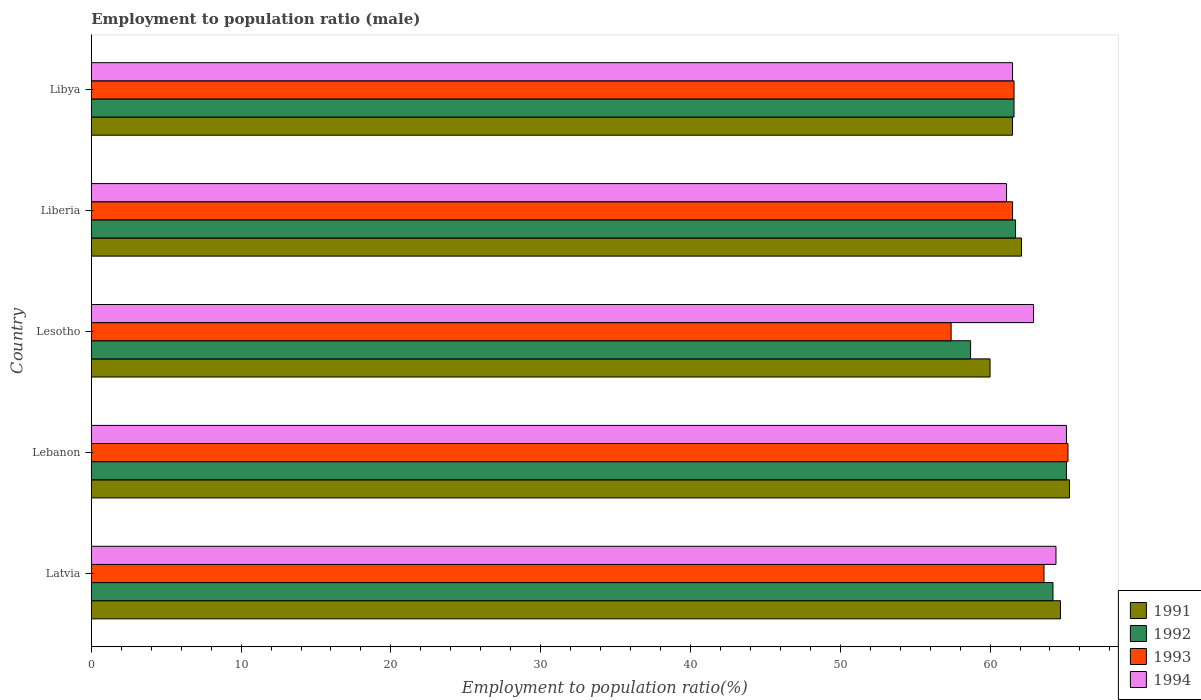How many groups of bars are there?
Make the answer very short. 5. How many bars are there on the 2nd tick from the top?
Offer a very short reply. 4. What is the label of the 2nd group of bars from the top?
Your answer should be compact. Liberia. In how many cases, is the number of bars for a given country not equal to the number of legend labels?
Provide a short and direct response. 0. What is the employment to population ratio in 1992 in Liberia?
Provide a succinct answer. 61.7. Across all countries, what is the maximum employment to population ratio in 1991?
Ensure brevity in your answer.  65.3. Across all countries, what is the minimum employment to population ratio in 1993?
Offer a terse response. 57.4. In which country was the employment to population ratio in 1991 maximum?
Keep it short and to the point. Lebanon. In which country was the employment to population ratio in 1991 minimum?
Your answer should be very brief. Lesotho. What is the total employment to population ratio in 1994 in the graph?
Offer a terse response. 315. What is the difference between the employment to population ratio in 1993 in Lesotho and that in Libya?
Your answer should be very brief. -4.2. What is the difference between the employment to population ratio in 1994 in Liberia and the employment to population ratio in 1992 in Lesotho?
Provide a succinct answer. 2.4. What is the average employment to population ratio in 1993 per country?
Ensure brevity in your answer.  61.86. What is the difference between the employment to population ratio in 1994 and employment to population ratio in 1991 in Lebanon?
Offer a very short reply. -0.2. What is the ratio of the employment to population ratio in 1991 in Latvia to that in Liberia?
Your response must be concise. 1.04. Is the employment to population ratio in 1991 in Lebanon less than that in Libya?
Provide a succinct answer. No. Is the difference between the employment to population ratio in 1994 in Latvia and Liberia greater than the difference between the employment to population ratio in 1991 in Latvia and Liberia?
Your answer should be very brief. Yes. What is the difference between the highest and the second highest employment to population ratio in 1991?
Your answer should be compact. 0.6. What is the difference between the highest and the lowest employment to population ratio in 1991?
Keep it short and to the point. 5.3. In how many countries, is the employment to population ratio in 1992 greater than the average employment to population ratio in 1992 taken over all countries?
Your answer should be compact. 2. What does the 2nd bar from the bottom in Liberia represents?
Your response must be concise. 1992. Is it the case that in every country, the sum of the employment to population ratio in 1994 and employment to population ratio in 1991 is greater than the employment to population ratio in 1992?
Keep it short and to the point. Yes. How many countries are there in the graph?
Your answer should be very brief. 5. How are the legend labels stacked?
Make the answer very short. Vertical. What is the title of the graph?
Your response must be concise. Employment to population ratio (male). What is the label or title of the Y-axis?
Ensure brevity in your answer.  Country. What is the Employment to population ratio(%) in 1991 in Latvia?
Ensure brevity in your answer.  64.7. What is the Employment to population ratio(%) of 1992 in Latvia?
Give a very brief answer. 64.2. What is the Employment to population ratio(%) of 1993 in Latvia?
Your answer should be very brief. 63.6. What is the Employment to population ratio(%) of 1994 in Latvia?
Provide a succinct answer. 64.4. What is the Employment to population ratio(%) of 1991 in Lebanon?
Provide a succinct answer. 65.3. What is the Employment to population ratio(%) of 1992 in Lebanon?
Your response must be concise. 65.1. What is the Employment to population ratio(%) in 1993 in Lebanon?
Give a very brief answer. 65.2. What is the Employment to population ratio(%) of 1994 in Lebanon?
Your answer should be very brief. 65.1. What is the Employment to population ratio(%) of 1991 in Lesotho?
Your answer should be very brief. 60. What is the Employment to population ratio(%) of 1992 in Lesotho?
Your response must be concise. 58.7. What is the Employment to population ratio(%) in 1993 in Lesotho?
Your answer should be very brief. 57.4. What is the Employment to population ratio(%) in 1994 in Lesotho?
Your answer should be very brief. 62.9. What is the Employment to population ratio(%) in 1991 in Liberia?
Provide a succinct answer. 62.1. What is the Employment to population ratio(%) of 1992 in Liberia?
Provide a short and direct response. 61.7. What is the Employment to population ratio(%) in 1993 in Liberia?
Ensure brevity in your answer.  61.5. What is the Employment to population ratio(%) in 1994 in Liberia?
Ensure brevity in your answer.  61.1. What is the Employment to population ratio(%) of 1991 in Libya?
Keep it short and to the point. 61.5. What is the Employment to population ratio(%) of 1992 in Libya?
Your answer should be compact. 61.6. What is the Employment to population ratio(%) in 1993 in Libya?
Offer a very short reply. 61.6. What is the Employment to population ratio(%) of 1994 in Libya?
Your response must be concise. 61.5. Across all countries, what is the maximum Employment to population ratio(%) of 1991?
Your response must be concise. 65.3. Across all countries, what is the maximum Employment to population ratio(%) of 1992?
Offer a very short reply. 65.1. Across all countries, what is the maximum Employment to population ratio(%) in 1993?
Provide a succinct answer. 65.2. Across all countries, what is the maximum Employment to population ratio(%) in 1994?
Make the answer very short. 65.1. Across all countries, what is the minimum Employment to population ratio(%) in 1991?
Provide a succinct answer. 60. Across all countries, what is the minimum Employment to population ratio(%) in 1992?
Your answer should be compact. 58.7. Across all countries, what is the minimum Employment to population ratio(%) in 1993?
Your answer should be very brief. 57.4. Across all countries, what is the minimum Employment to population ratio(%) of 1994?
Offer a very short reply. 61.1. What is the total Employment to population ratio(%) of 1991 in the graph?
Your answer should be compact. 313.6. What is the total Employment to population ratio(%) of 1992 in the graph?
Provide a succinct answer. 311.3. What is the total Employment to population ratio(%) in 1993 in the graph?
Keep it short and to the point. 309.3. What is the total Employment to population ratio(%) of 1994 in the graph?
Your response must be concise. 315. What is the difference between the Employment to population ratio(%) of 1993 in Latvia and that in Lebanon?
Ensure brevity in your answer.  -1.6. What is the difference between the Employment to population ratio(%) of 1994 in Latvia and that in Lebanon?
Provide a short and direct response. -0.7. What is the difference between the Employment to population ratio(%) in 1992 in Latvia and that in Lesotho?
Ensure brevity in your answer.  5.5. What is the difference between the Employment to population ratio(%) in 1994 in Latvia and that in Liberia?
Keep it short and to the point. 3.3. What is the difference between the Employment to population ratio(%) in 1992 in Lebanon and that in Lesotho?
Make the answer very short. 6.4. What is the difference between the Employment to population ratio(%) of 1992 in Lebanon and that in Liberia?
Make the answer very short. 3.4. What is the difference between the Employment to population ratio(%) in 1992 in Lebanon and that in Libya?
Offer a terse response. 3.5. What is the difference between the Employment to population ratio(%) in 1992 in Lesotho and that in Liberia?
Your response must be concise. -3. What is the difference between the Employment to population ratio(%) of 1993 in Lesotho and that in Liberia?
Offer a very short reply. -4.1. What is the difference between the Employment to population ratio(%) of 1994 in Lesotho and that in Liberia?
Ensure brevity in your answer.  1.8. What is the difference between the Employment to population ratio(%) in 1991 in Lesotho and that in Libya?
Ensure brevity in your answer.  -1.5. What is the difference between the Employment to population ratio(%) of 1991 in Liberia and that in Libya?
Your answer should be compact. 0.6. What is the difference between the Employment to population ratio(%) in 1992 in Liberia and that in Libya?
Provide a succinct answer. 0.1. What is the difference between the Employment to population ratio(%) in 1991 in Latvia and the Employment to population ratio(%) in 1992 in Lebanon?
Provide a short and direct response. -0.4. What is the difference between the Employment to population ratio(%) in 1991 in Latvia and the Employment to population ratio(%) in 1992 in Lesotho?
Make the answer very short. 6. What is the difference between the Employment to population ratio(%) of 1991 in Latvia and the Employment to population ratio(%) of 1993 in Lesotho?
Offer a terse response. 7.3. What is the difference between the Employment to population ratio(%) of 1991 in Latvia and the Employment to population ratio(%) of 1994 in Lesotho?
Give a very brief answer. 1.8. What is the difference between the Employment to population ratio(%) of 1993 in Latvia and the Employment to population ratio(%) of 1994 in Lesotho?
Offer a terse response. 0.7. What is the difference between the Employment to population ratio(%) in 1991 in Latvia and the Employment to population ratio(%) in 1992 in Liberia?
Offer a very short reply. 3. What is the difference between the Employment to population ratio(%) in 1991 in Latvia and the Employment to population ratio(%) in 1993 in Liberia?
Keep it short and to the point. 3.2. What is the difference between the Employment to population ratio(%) of 1991 in Latvia and the Employment to population ratio(%) of 1994 in Liberia?
Keep it short and to the point. 3.6. What is the difference between the Employment to population ratio(%) in 1993 in Latvia and the Employment to population ratio(%) in 1994 in Liberia?
Offer a terse response. 2.5. What is the difference between the Employment to population ratio(%) in 1991 in Latvia and the Employment to population ratio(%) in 1992 in Libya?
Provide a short and direct response. 3.1. What is the difference between the Employment to population ratio(%) of 1993 in Latvia and the Employment to population ratio(%) of 1994 in Libya?
Your answer should be very brief. 2.1. What is the difference between the Employment to population ratio(%) in 1991 in Lebanon and the Employment to population ratio(%) in 1992 in Lesotho?
Offer a very short reply. 6.6. What is the difference between the Employment to population ratio(%) of 1991 in Lebanon and the Employment to population ratio(%) of 1994 in Lesotho?
Make the answer very short. 2.4. What is the difference between the Employment to population ratio(%) of 1992 in Lebanon and the Employment to population ratio(%) of 1994 in Lesotho?
Keep it short and to the point. 2.2. What is the difference between the Employment to population ratio(%) in 1993 in Lebanon and the Employment to population ratio(%) in 1994 in Lesotho?
Your answer should be compact. 2.3. What is the difference between the Employment to population ratio(%) in 1991 in Lebanon and the Employment to population ratio(%) in 1993 in Liberia?
Offer a terse response. 3.8. What is the difference between the Employment to population ratio(%) in 1992 in Lebanon and the Employment to population ratio(%) in 1993 in Liberia?
Ensure brevity in your answer.  3.6. What is the difference between the Employment to population ratio(%) of 1993 in Lebanon and the Employment to population ratio(%) of 1994 in Liberia?
Give a very brief answer. 4.1. What is the difference between the Employment to population ratio(%) of 1992 in Lebanon and the Employment to population ratio(%) of 1994 in Libya?
Keep it short and to the point. 3.6. What is the difference between the Employment to population ratio(%) of 1991 in Lesotho and the Employment to population ratio(%) of 1992 in Liberia?
Your answer should be very brief. -1.7. What is the difference between the Employment to population ratio(%) in 1991 in Lesotho and the Employment to population ratio(%) in 1993 in Liberia?
Offer a terse response. -1.5. What is the difference between the Employment to population ratio(%) in 1991 in Lesotho and the Employment to population ratio(%) in 1994 in Liberia?
Provide a succinct answer. -1.1. What is the difference between the Employment to population ratio(%) of 1992 in Lesotho and the Employment to population ratio(%) of 1993 in Liberia?
Ensure brevity in your answer.  -2.8. What is the difference between the Employment to population ratio(%) of 1993 in Lesotho and the Employment to population ratio(%) of 1994 in Liberia?
Offer a very short reply. -3.7. What is the difference between the Employment to population ratio(%) of 1991 in Lesotho and the Employment to population ratio(%) of 1992 in Libya?
Ensure brevity in your answer.  -1.6. What is the difference between the Employment to population ratio(%) in 1993 in Lesotho and the Employment to population ratio(%) in 1994 in Libya?
Your response must be concise. -4.1. What is the difference between the Employment to population ratio(%) of 1991 in Liberia and the Employment to population ratio(%) of 1992 in Libya?
Offer a very short reply. 0.5. What is the difference between the Employment to population ratio(%) in 1991 in Liberia and the Employment to population ratio(%) in 1993 in Libya?
Ensure brevity in your answer.  0.5. What is the difference between the Employment to population ratio(%) in 1992 in Liberia and the Employment to population ratio(%) in 1993 in Libya?
Your answer should be very brief. 0.1. What is the average Employment to population ratio(%) of 1991 per country?
Give a very brief answer. 62.72. What is the average Employment to population ratio(%) of 1992 per country?
Make the answer very short. 62.26. What is the average Employment to population ratio(%) in 1993 per country?
Provide a short and direct response. 61.86. What is the average Employment to population ratio(%) in 1994 per country?
Offer a terse response. 63. What is the difference between the Employment to population ratio(%) in 1991 and Employment to population ratio(%) in 1992 in Latvia?
Your answer should be compact. 0.5. What is the difference between the Employment to population ratio(%) in 1992 and Employment to population ratio(%) in 1993 in Latvia?
Offer a terse response. 0.6. What is the difference between the Employment to population ratio(%) in 1992 and Employment to population ratio(%) in 1994 in Latvia?
Your answer should be very brief. -0.2. What is the difference between the Employment to population ratio(%) of 1993 and Employment to population ratio(%) of 1994 in Latvia?
Your response must be concise. -0.8. What is the difference between the Employment to population ratio(%) in 1991 and Employment to population ratio(%) in 1992 in Lebanon?
Provide a succinct answer. 0.2. What is the difference between the Employment to population ratio(%) in 1991 and Employment to population ratio(%) in 1994 in Lebanon?
Provide a short and direct response. 0.2. What is the difference between the Employment to population ratio(%) of 1993 and Employment to population ratio(%) of 1994 in Lebanon?
Provide a short and direct response. 0.1. What is the difference between the Employment to population ratio(%) in 1991 and Employment to population ratio(%) in 1992 in Lesotho?
Make the answer very short. 1.3. What is the difference between the Employment to population ratio(%) of 1991 and Employment to population ratio(%) of 1994 in Lesotho?
Your answer should be very brief. -2.9. What is the difference between the Employment to population ratio(%) in 1992 and Employment to population ratio(%) in 1993 in Lesotho?
Your response must be concise. 1.3. What is the difference between the Employment to population ratio(%) in 1993 and Employment to population ratio(%) in 1994 in Lesotho?
Offer a terse response. -5.5. What is the difference between the Employment to population ratio(%) of 1991 and Employment to population ratio(%) of 1994 in Liberia?
Provide a succinct answer. 1. What is the difference between the Employment to population ratio(%) in 1991 and Employment to population ratio(%) in 1992 in Libya?
Ensure brevity in your answer.  -0.1. What is the difference between the Employment to population ratio(%) in 1991 and Employment to population ratio(%) in 1994 in Libya?
Provide a succinct answer. 0. What is the difference between the Employment to population ratio(%) in 1992 and Employment to population ratio(%) in 1994 in Libya?
Offer a very short reply. 0.1. What is the ratio of the Employment to population ratio(%) of 1992 in Latvia to that in Lebanon?
Provide a short and direct response. 0.99. What is the ratio of the Employment to population ratio(%) in 1993 in Latvia to that in Lebanon?
Your answer should be very brief. 0.98. What is the ratio of the Employment to population ratio(%) in 1994 in Latvia to that in Lebanon?
Make the answer very short. 0.99. What is the ratio of the Employment to population ratio(%) of 1991 in Latvia to that in Lesotho?
Offer a terse response. 1.08. What is the ratio of the Employment to population ratio(%) in 1992 in Latvia to that in Lesotho?
Your answer should be compact. 1.09. What is the ratio of the Employment to population ratio(%) in 1993 in Latvia to that in Lesotho?
Your answer should be compact. 1.11. What is the ratio of the Employment to population ratio(%) of 1994 in Latvia to that in Lesotho?
Offer a very short reply. 1.02. What is the ratio of the Employment to population ratio(%) of 1991 in Latvia to that in Liberia?
Keep it short and to the point. 1.04. What is the ratio of the Employment to population ratio(%) in 1992 in Latvia to that in Liberia?
Keep it short and to the point. 1.04. What is the ratio of the Employment to population ratio(%) of 1993 in Latvia to that in Liberia?
Your answer should be very brief. 1.03. What is the ratio of the Employment to population ratio(%) of 1994 in Latvia to that in Liberia?
Offer a very short reply. 1.05. What is the ratio of the Employment to population ratio(%) of 1991 in Latvia to that in Libya?
Offer a very short reply. 1.05. What is the ratio of the Employment to population ratio(%) in 1992 in Latvia to that in Libya?
Provide a succinct answer. 1.04. What is the ratio of the Employment to population ratio(%) in 1993 in Latvia to that in Libya?
Your answer should be very brief. 1.03. What is the ratio of the Employment to population ratio(%) in 1994 in Latvia to that in Libya?
Keep it short and to the point. 1.05. What is the ratio of the Employment to population ratio(%) of 1991 in Lebanon to that in Lesotho?
Give a very brief answer. 1.09. What is the ratio of the Employment to population ratio(%) in 1992 in Lebanon to that in Lesotho?
Give a very brief answer. 1.11. What is the ratio of the Employment to population ratio(%) in 1993 in Lebanon to that in Lesotho?
Provide a succinct answer. 1.14. What is the ratio of the Employment to population ratio(%) of 1994 in Lebanon to that in Lesotho?
Give a very brief answer. 1.03. What is the ratio of the Employment to population ratio(%) of 1991 in Lebanon to that in Liberia?
Make the answer very short. 1.05. What is the ratio of the Employment to population ratio(%) of 1992 in Lebanon to that in Liberia?
Give a very brief answer. 1.06. What is the ratio of the Employment to population ratio(%) of 1993 in Lebanon to that in Liberia?
Your response must be concise. 1.06. What is the ratio of the Employment to population ratio(%) of 1994 in Lebanon to that in Liberia?
Your answer should be compact. 1.07. What is the ratio of the Employment to population ratio(%) of 1991 in Lebanon to that in Libya?
Make the answer very short. 1.06. What is the ratio of the Employment to population ratio(%) in 1992 in Lebanon to that in Libya?
Provide a short and direct response. 1.06. What is the ratio of the Employment to population ratio(%) in 1993 in Lebanon to that in Libya?
Offer a terse response. 1.06. What is the ratio of the Employment to population ratio(%) of 1994 in Lebanon to that in Libya?
Offer a very short reply. 1.06. What is the ratio of the Employment to population ratio(%) of 1991 in Lesotho to that in Liberia?
Ensure brevity in your answer.  0.97. What is the ratio of the Employment to population ratio(%) in 1992 in Lesotho to that in Liberia?
Offer a terse response. 0.95. What is the ratio of the Employment to population ratio(%) of 1993 in Lesotho to that in Liberia?
Your response must be concise. 0.93. What is the ratio of the Employment to population ratio(%) in 1994 in Lesotho to that in Liberia?
Your response must be concise. 1.03. What is the ratio of the Employment to population ratio(%) of 1991 in Lesotho to that in Libya?
Offer a very short reply. 0.98. What is the ratio of the Employment to population ratio(%) in 1992 in Lesotho to that in Libya?
Keep it short and to the point. 0.95. What is the ratio of the Employment to population ratio(%) of 1993 in Lesotho to that in Libya?
Ensure brevity in your answer.  0.93. What is the ratio of the Employment to population ratio(%) of 1994 in Lesotho to that in Libya?
Your answer should be compact. 1.02. What is the ratio of the Employment to population ratio(%) of 1991 in Liberia to that in Libya?
Give a very brief answer. 1.01. What is the ratio of the Employment to population ratio(%) of 1994 in Liberia to that in Libya?
Your answer should be compact. 0.99. What is the difference between the highest and the second highest Employment to population ratio(%) in 1991?
Your answer should be very brief. 0.6. 